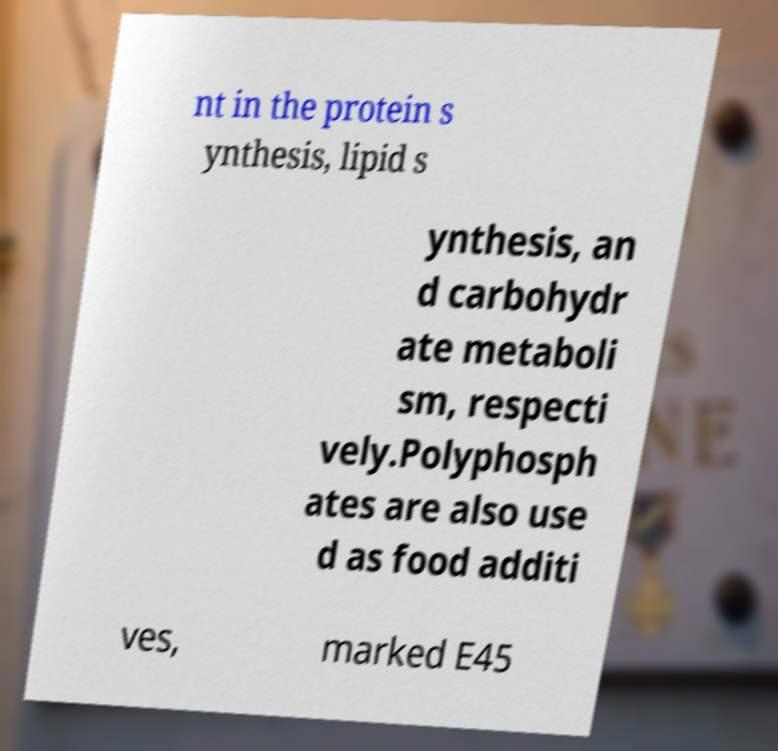Could you extract and type out the text from this image? nt in the protein s ynthesis, lipid s ynthesis, an d carbohydr ate metaboli sm, respecti vely.Polyphosph ates are also use d as food additi ves, marked E45 